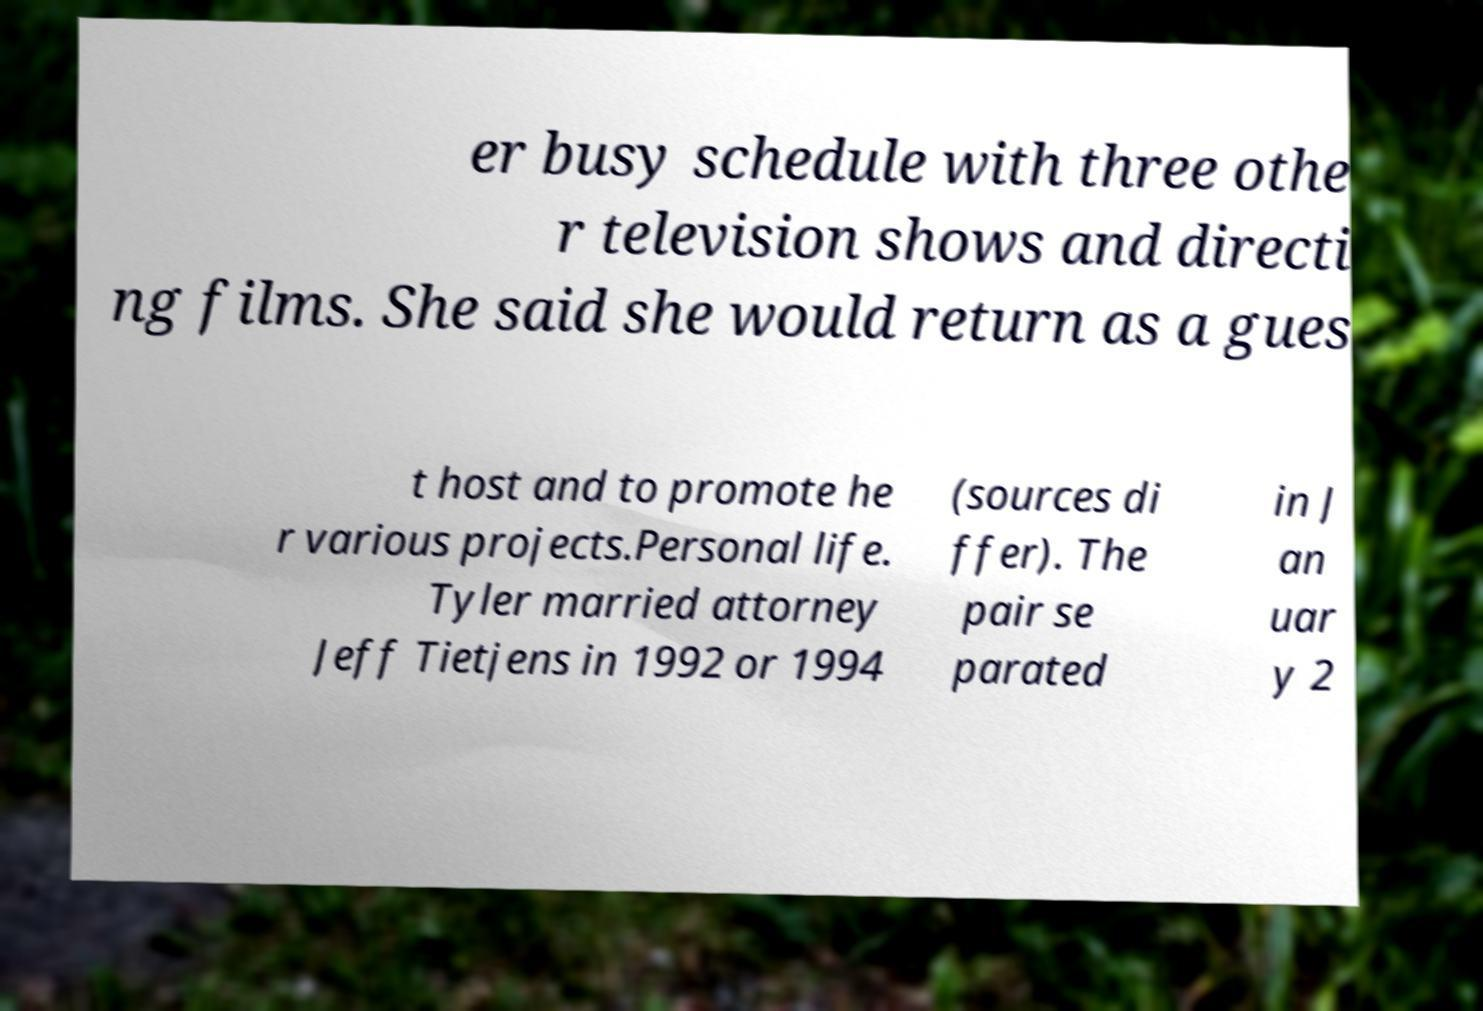There's text embedded in this image that I need extracted. Can you transcribe it verbatim? er busy schedule with three othe r television shows and directi ng films. She said she would return as a gues t host and to promote he r various projects.Personal life. Tyler married attorney Jeff Tietjens in 1992 or 1994 (sources di ffer). The pair se parated in J an uar y 2 